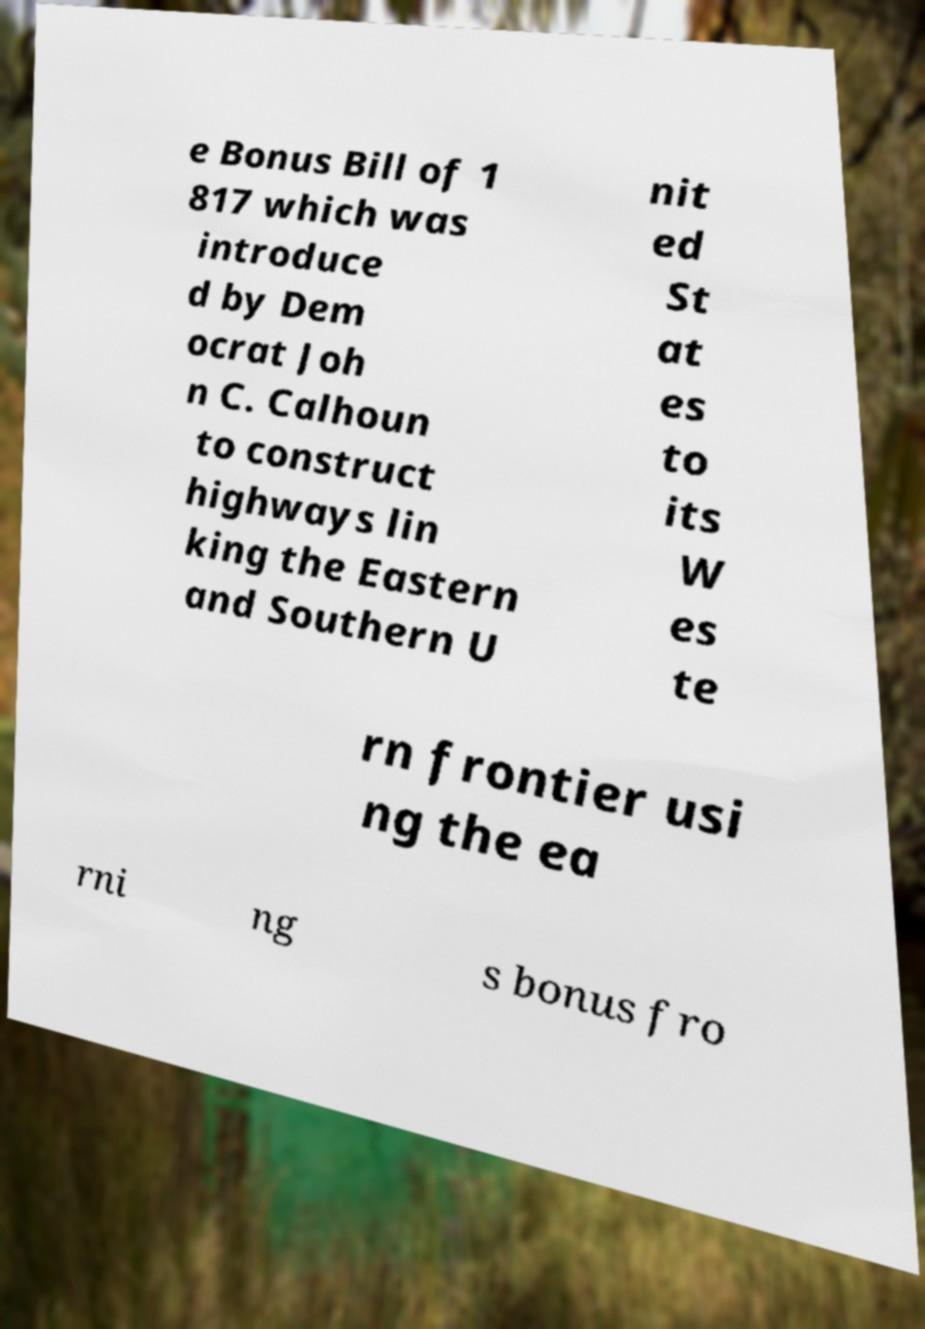Please identify and transcribe the text found in this image. e Bonus Bill of 1 817 which was introduce d by Dem ocrat Joh n C. Calhoun to construct highways lin king the Eastern and Southern U nit ed St at es to its W es te rn frontier usi ng the ea rni ng s bonus fro 